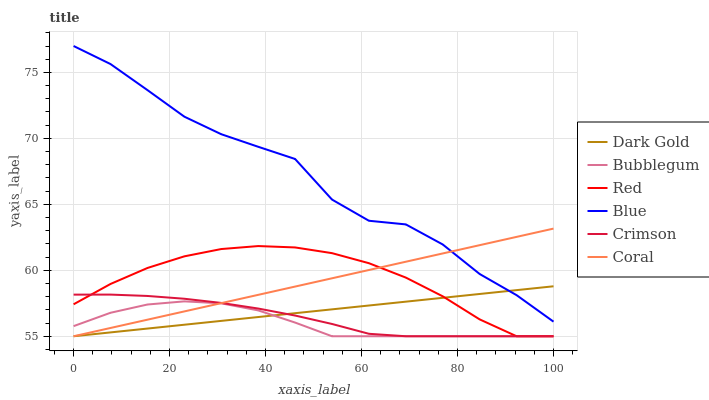Does Bubblegum have the minimum area under the curve?
Answer yes or no. Yes. Does Blue have the maximum area under the curve?
Answer yes or no. Yes. Does Dark Gold have the minimum area under the curve?
Answer yes or no. No. Does Dark Gold have the maximum area under the curve?
Answer yes or no. No. Is Dark Gold the smoothest?
Answer yes or no. Yes. Is Blue the roughest?
Answer yes or no. Yes. Is Coral the smoothest?
Answer yes or no. No. Is Coral the roughest?
Answer yes or no. No. Does Dark Gold have the lowest value?
Answer yes or no. Yes. Does Blue have the highest value?
Answer yes or no. Yes. Does Dark Gold have the highest value?
Answer yes or no. No. Is Bubblegum less than Blue?
Answer yes or no. Yes. Is Blue greater than Bubblegum?
Answer yes or no. Yes. Does Blue intersect Coral?
Answer yes or no. Yes. Is Blue less than Coral?
Answer yes or no. No. Is Blue greater than Coral?
Answer yes or no. No. Does Bubblegum intersect Blue?
Answer yes or no. No. 